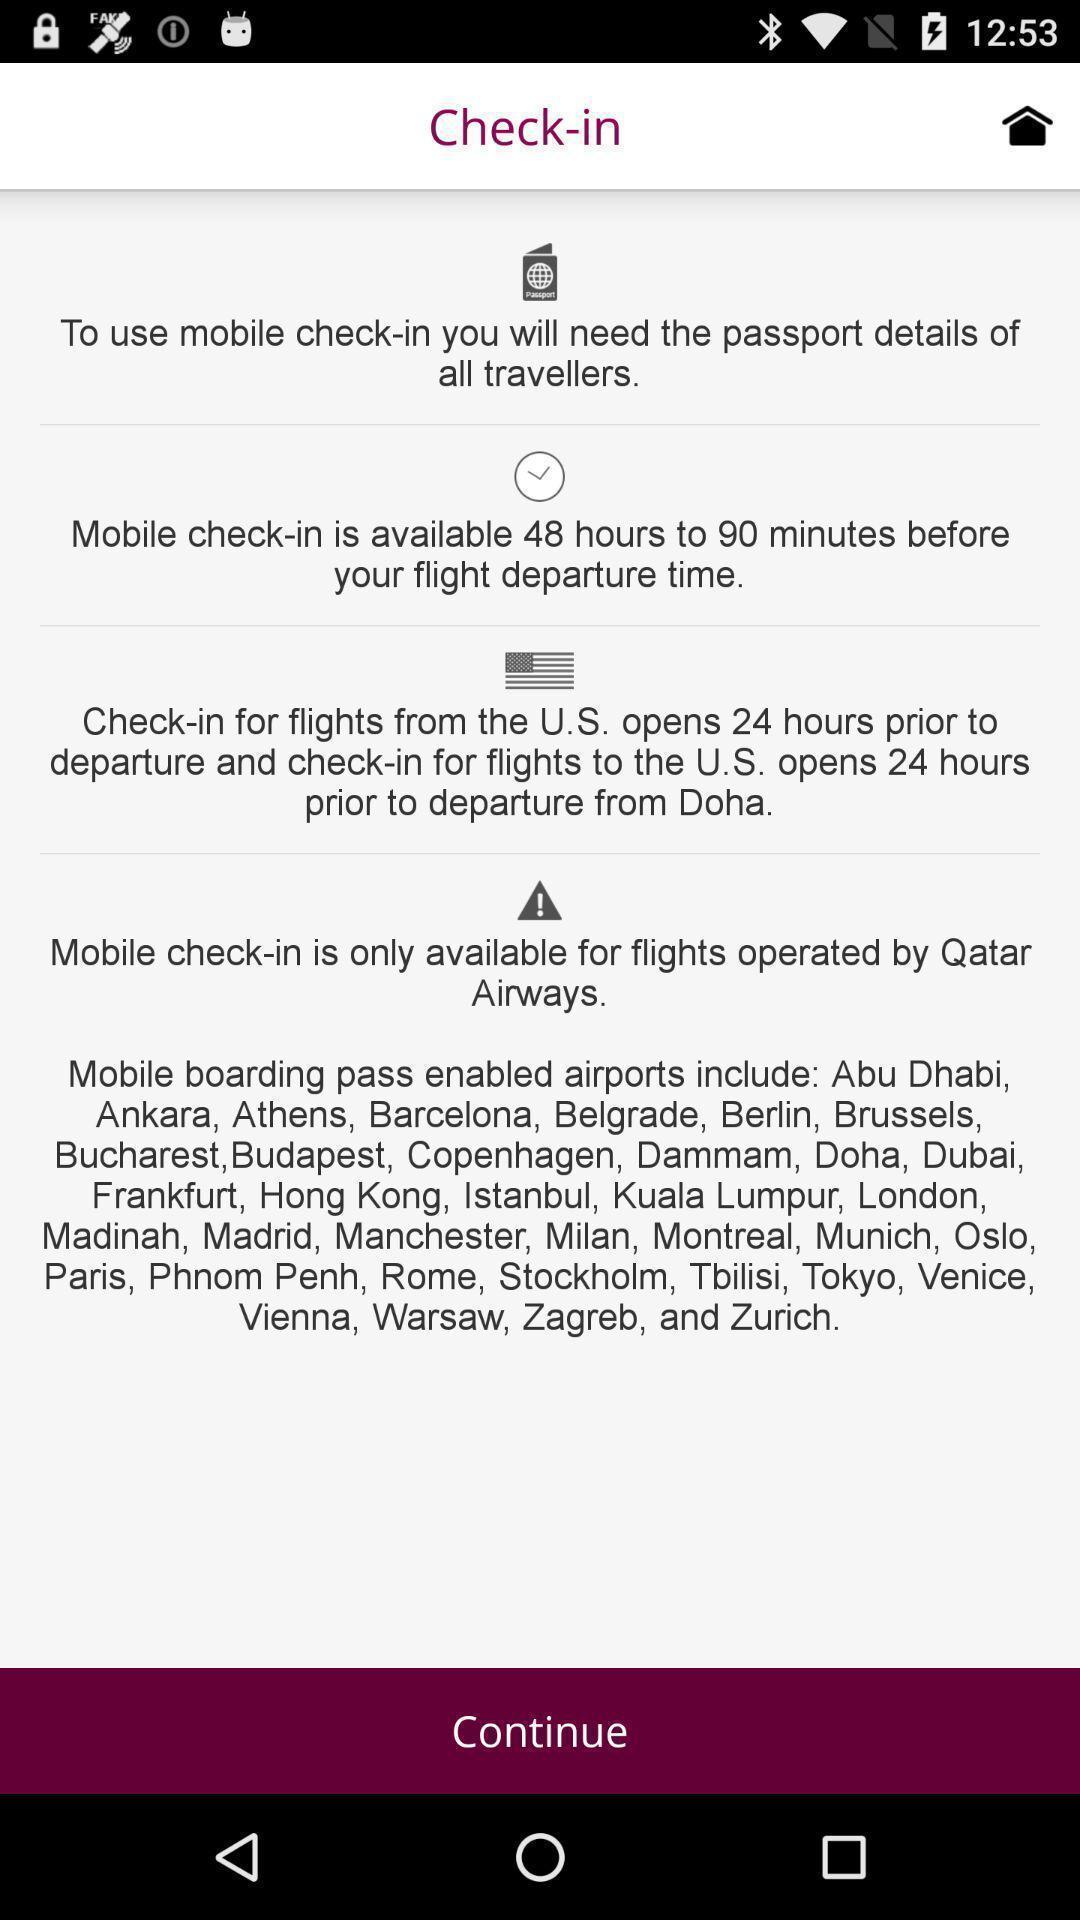Give me a summary of this screen capture. Page displaying the information about check-in. 